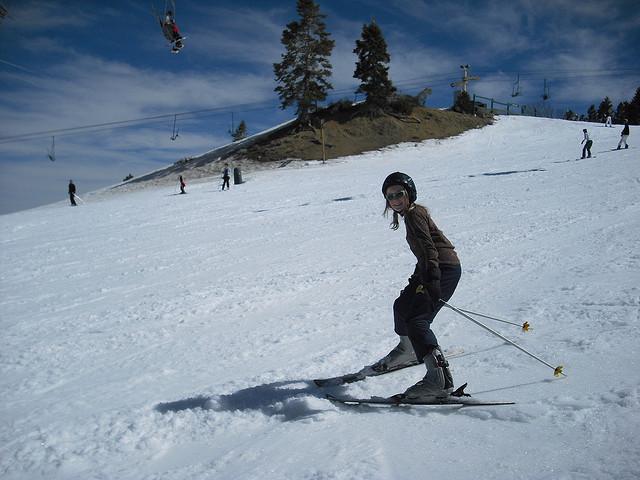Is he on a snowboard?
Quick response, please. No. What sport is the person playing?
Be succinct. Skiing. What are the green objects in the background?
Give a very brief answer. Trees. What color helmet is this person wearing?
Answer briefly. Black. Does the photo picture an easier type of ski hill?
Answer briefly. Yes. Is this person skiing?
Concise answer only. Yes. What is on the skiers head?
Concise answer only. Helmet. Is a shadow cast?
Be succinct. Yes. Are his skies far apart?
Quick response, please. Yes. Is this run a double black diamond?
Be succinct. No. Is the snow in this picture probably natural, or probably man-made?
Answer briefly. Natural. Is the skier in this picture wearing safety gear?
Write a very short answer. Yes. If the person continues in their current direction, on what side will he leave the frame?
Keep it brief. Left. How many people do you see?
Concise answer only. 8. Is there a lot of snow in the distance?
Answer briefly. Yes. 